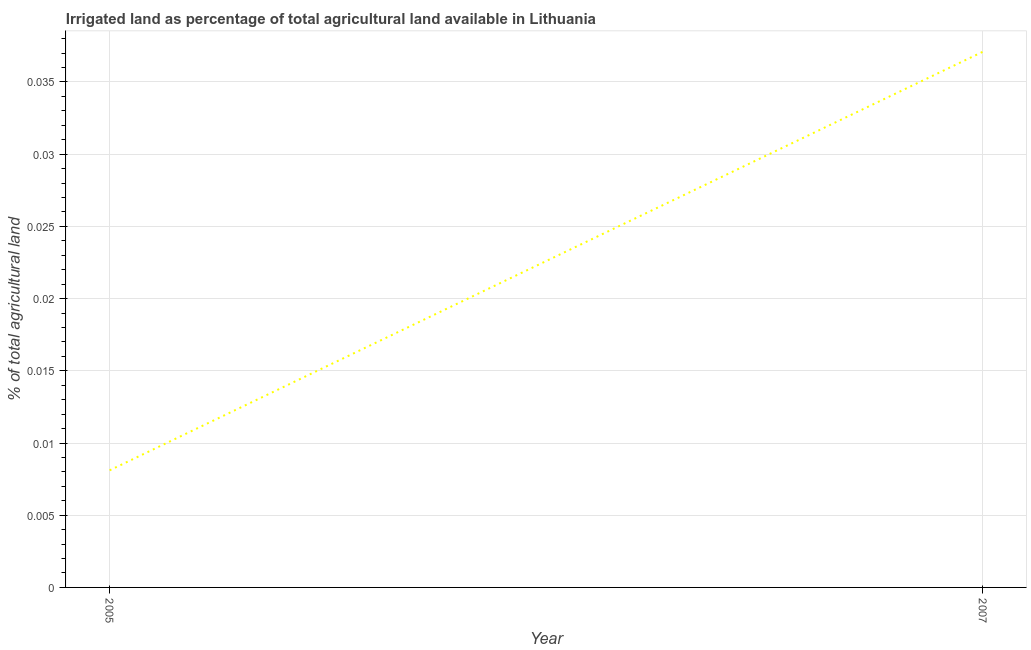What is the percentage of agricultural irrigated land in 2005?
Give a very brief answer. 0.01. Across all years, what is the maximum percentage of agricultural irrigated land?
Keep it short and to the point. 0.04. Across all years, what is the minimum percentage of agricultural irrigated land?
Provide a short and direct response. 0.01. In which year was the percentage of agricultural irrigated land minimum?
Your answer should be very brief. 2005. What is the sum of the percentage of agricultural irrigated land?
Offer a terse response. 0.05. What is the difference between the percentage of agricultural irrigated land in 2005 and 2007?
Your answer should be very brief. -0.03. What is the average percentage of agricultural irrigated land per year?
Offer a very short reply. 0.02. What is the median percentage of agricultural irrigated land?
Give a very brief answer. 0.02. Do a majority of the years between 2005 and 2007 (inclusive) have percentage of agricultural irrigated land greater than 0.027000000000000003 %?
Keep it short and to the point. No. What is the ratio of the percentage of agricultural irrigated land in 2005 to that in 2007?
Ensure brevity in your answer.  0.22. Does the percentage of agricultural irrigated land monotonically increase over the years?
Provide a short and direct response. Yes. How many years are there in the graph?
Your response must be concise. 2. What is the difference between two consecutive major ticks on the Y-axis?
Your response must be concise. 0.01. What is the title of the graph?
Ensure brevity in your answer.  Irrigated land as percentage of total agricultural land available in Lithuania. What is the label or title of the Y-axis?
Provide a short and direct response. % of total agricultural land. What is the % of total agricultural land of 2005?
Offer a very short reply. 0.01. What is the % of total agricultural land of 2007?
Offer a terse response. 0.04. What is the difference between the % of total agricultural land in 2005 and 2007?
Keep it short and to the point. -0.03. What is the ratio of the % of total agricultural land in 2005 to that in 2007?
Provide a succinct answer. 0.22. 